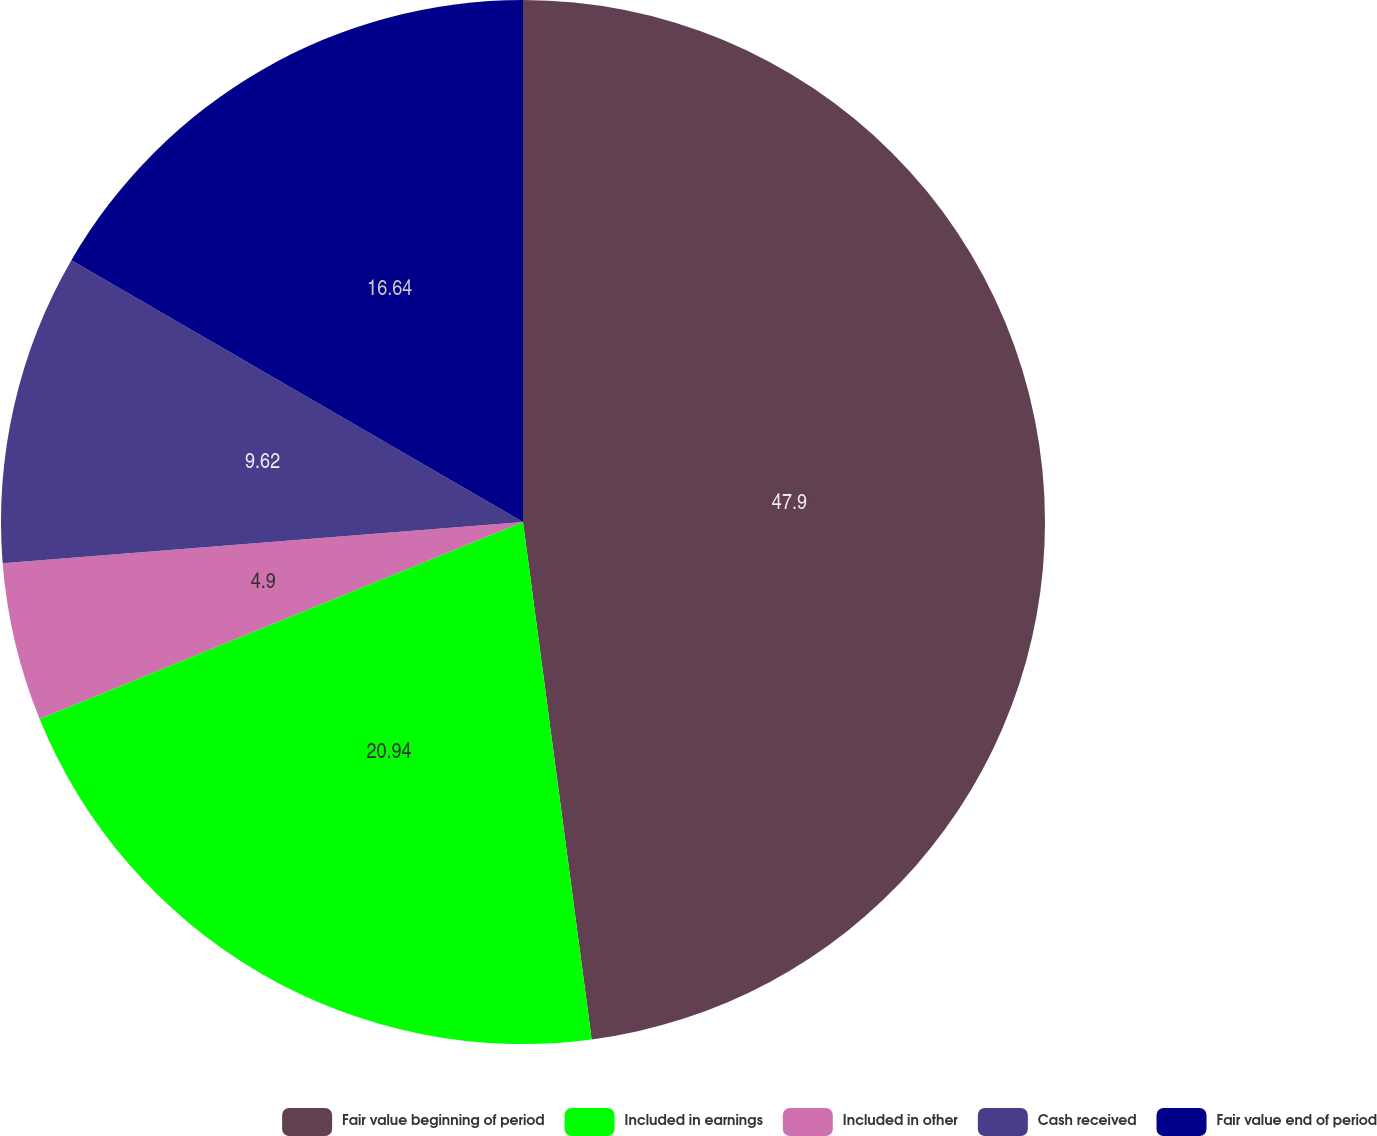Convert chart to OTSL. <chart><loc_0><loc_0><loc_500><loc_500><pie_chart><fcel>Fair value beginning of period<fcel>Included in earnings<fcel>Included in other<fcel>Cash received<fcel>Fair value end of period<nl><fcel>47.9%<fcel>20.94%<fcel>4.9%<fcel>9.62%<fcel>16.64%<nl></chart> 